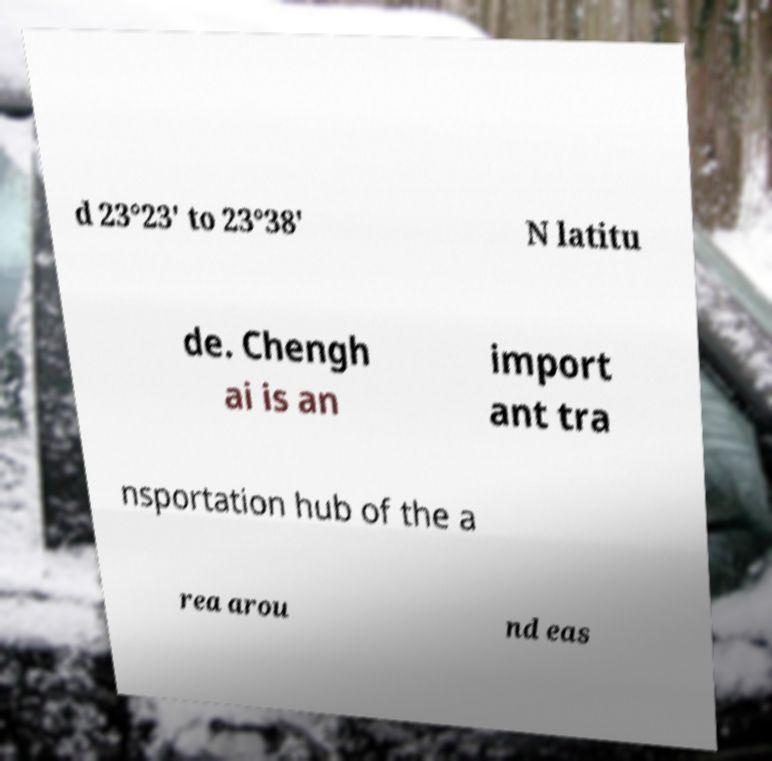Could you assist in decoding the text presented in this image and type it out clearly? d 23°23' to 23°38' N latitu de. Chengh ai is an import ant tra nsportation hub of the a rea arou nd eas 